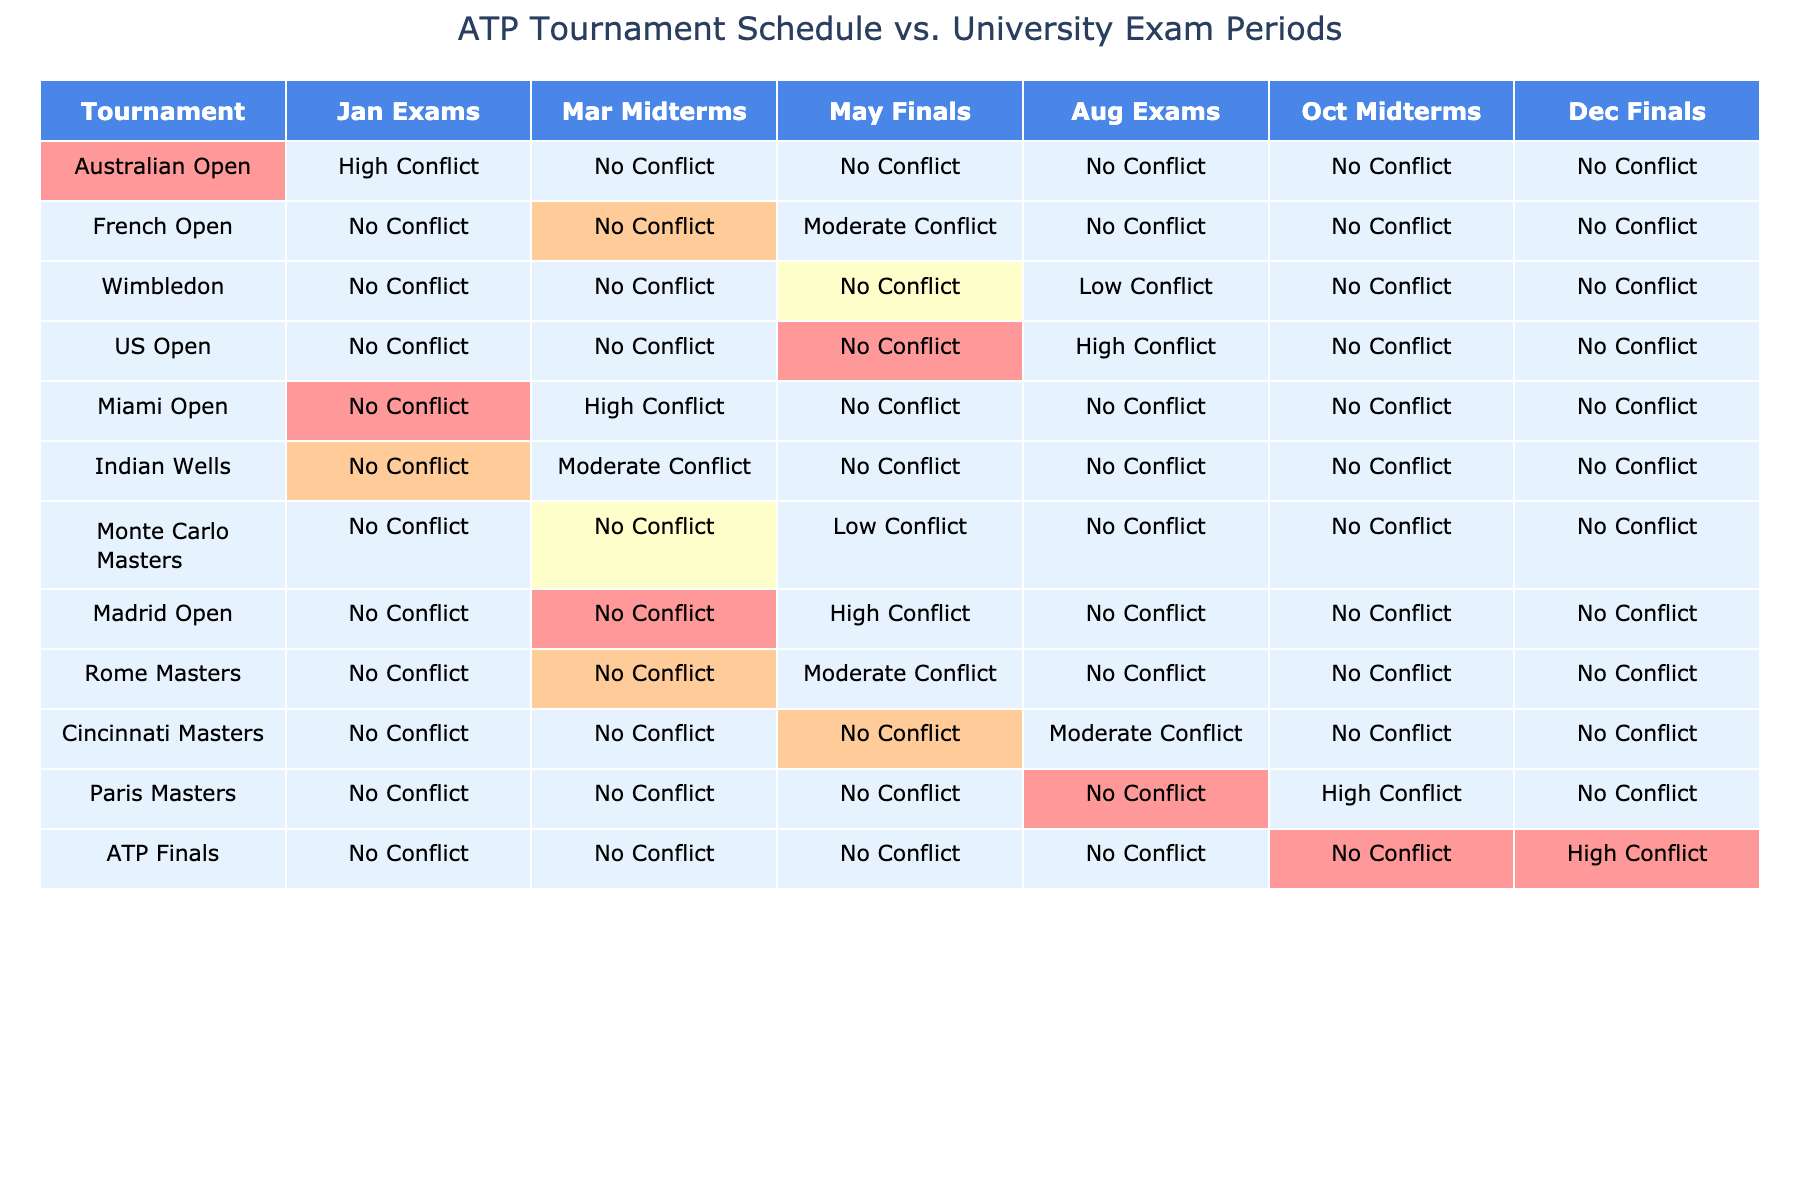What tournament has the highest conflict during the January exam period? Looking at the table, the Australian Open is marked as having a 'High Conflict' during the January exam period.
Answer: Australian Open Is there any tournament that has a moderate conflict during the May finals? The table shows that the French Open and the Madrid Open both indicate a 'Moderate Conflict' during the May finals.
Answer: Yes How many tournaments have a low conflict during the August exams? In the table, only Wimbledon and Monte Carlo Masters have a 'Low Conflict' during the August exams, making it a total of two tournaments.
Answer: 2 Which tournament has a high conflict during the October midterms? The table indicates that the Paris Masters is marked as having a 'High Conflict' during the October midterms.
Answer: Paris Masters For which tournament is there a no conflict in all exam periods? By reviewing the table, we find that both the Wimbledon and the Cincinnati Masters have 'No Conflict' across all exam periods.
Answer: Wimbledon, Cincinnati Masters Can you identify if there are more tournaments with high conflicts or low conflicts during the August exams? The table shows that there are two tournaments with a 'High Conflict' (US Open) and two with a 'Low Conflict' (Wimbledon, Monte Carlo Masters) during the August exams, leading to a tie.
Answer: Tie What is the total number of tournaments that have no conflicts during the December finals? The table displays that six tournaments (Australian Open, French Open, Wimbledon, Miami Open, Indian Wells, Monte Carlo Masters, Cincinnati Masters) have 'No Conflict' during the December finals.
Answer: 6 Which tournament shows the most exam periods with high conflict? In evaluating the table, the US Open has 'High Conflict' during the August exams, while the ATP Finals show 'High Conflict' during the December finals. Hence, both tournaments have high conflict in one exam period, but no tournament shows it in multiple periods.
Answer: None Is there a tournament that has a conflict in every exam period? The table indicates that all tournaments have varying levels of conflict, with none presenting a conflict in every exam period.
Answer: No Which month has the most tournaments with a moderate conflict? A review of the table shows that March has three tournaments (Miami Open, Indian Wells, and Rome Masters) with 'Moderate Conflict', which is the highest across the exam periods.
Answer: March 